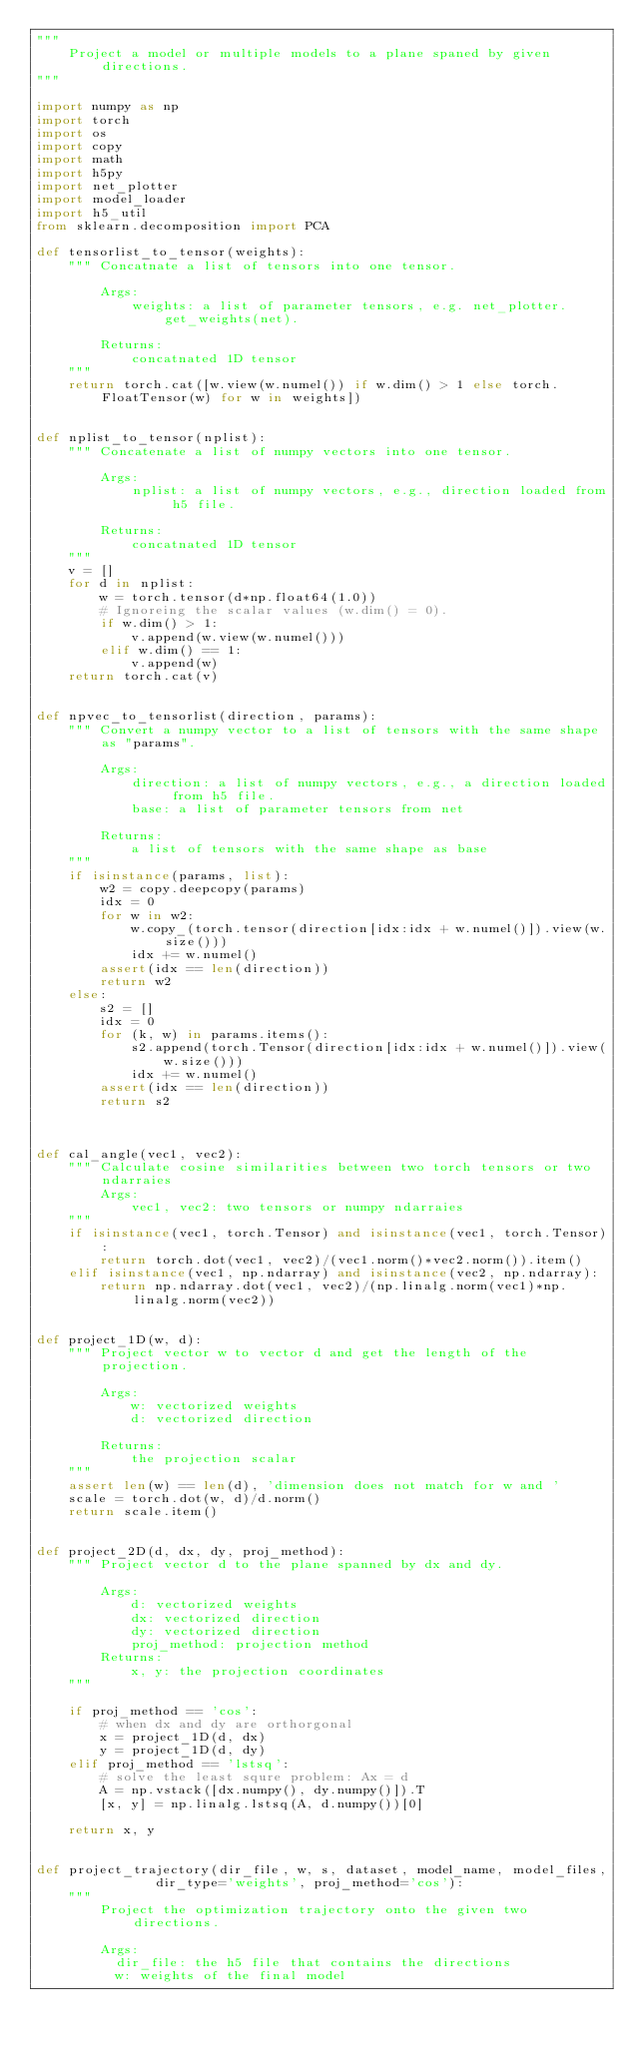Convert code to text. <code><loc_0><loc_0><loc_500><loc_500><_Python_>"""
    Project a model or multiple models to a plane spaned by given directions.
"""

import numpy as np
import torch
import os
import copy
import math
import h5py
import net_plotter
import model_loader
import h5_util
from sklearn.decomposition import PCA

def tensorlist_to_tensor(weights):
    """ Concatnate a list of tensors into one tensor.

        Args:
            weights: a list of parameter tensors, e.g. net_plotter.get_weights(net).

        Returns:
            concatnated 1D tensor
    """
    return torch.cat([w.view(w.numel()) if w.dim() > 1 else torch.FloatTensor(w) for w in weights])


def nplist_to_tensor(nplist):
    """ Concatenate a list of numpy vectors into one tensor.

        Args:
            nplist: a list of numpy vectors, e.g., direction loaded from h5 file.

        Returns:
            concatnated 1D tensor
    """
    v = []
    for d in nplist:
        w = torch.tensor(d*np.float64(1.0))
        # Ignoreing the scalar values (w.dim() = 0).
        if w.dim() > 1:
            v.append(w.view(w.numel()))
        elif w.dim() == 1:
            v.append(w)
    return torch.cat(v)


def npvec_to_tensorlist(direction, params):
    """ Convert a numpy vector to a list of tensors with the same shape as "params".

        Args:
            direction: a list of numpy vectors, e.g., a direction loaded from h5 file.
            base: a list of parameter tensors from net

        Returns:
            a list of tensors with the same shape as base
    """
    if isinstance(params, list):
        w2 = copy.deepcopy(params)
        idx = 0
        for w in w2:
            w.copy_(torch.tensor(direction[idx:idx + w.numel()]).view(w.size()))
            idx += w.numel()
        assert(idx == len(direction))
        return w2
    else:
        s2 = []
        idx = 0
        for (k, w) in params.items():
            s2.append(torch.Tensor(direction[idx:idx + w.numel()]).view(w.size()))
            idx += w.numel()
        assert(idx == len(direction))
        return s2



def cal_angle(vec1, vec2):
    """ Calculate cosine similarities between two torch tensors or two ndarraies
        Args:
            vec1, vec2: two tensors or numpy ndarraies
    """
    if isinstance(vec1, torch.Tensor) and isinstance(vec1, torch.Tensor):
        return torch.dot(vec1, vec2)/(vec1.norm()*vec2.norm()).item()
    elif isinstance(vec1, np.ndarray) and isinstance(vec2, np.ndarray):
        return np.ndarray.dot(vec1, vec2)/(np.linalg.norm(vec1)*np.linalg.norm(vec2))


def project_1D(w, d):
    """ Project vector w to vector d and get the length of the projection.

        Args:
            w: vectorized weights
            d: vectorized direction

        Returns:
            the projection scalar
    """
    assert len(w) == len(d), 'dimension does not match for w and '
    scale = torch.dot(w, d)/d.norm()
    return scale.item()


def project_2D(d, dx, dy, proj_method):
    """ Project vector d to the plane spanned by dx and dy.

        Args:
            d: vectorized weights
            dx: vectorized direction
            dy: vectorized direction
            proj_method: projection method
        Returns:
            x, y: the projection coordinates
    """

    if proj_method == 'cos':
        # when dx and dy are orthorgonal
        x = project_1D(d, dx)
        y = project_1D(d, dy)
    elif proj_method == 'lstsq':
        # solve the least squre problem: Ax = d
        A = np.vstack([dx.numpy(), dy.numpy()]).T
        [x, y] = np.linalg.lstsq(A, d.numpy())[0]

    return x, y


def project_trajectory(dir_file, w, s, dataset, model_name, model_files,
               dir_type='weights', proj_method='cos'):
    """
        Project the optimization trajectory onto the given two directions.

        Args:
          dir_file: the h5 file that contains the directions
          w: weights of the final model</code> 